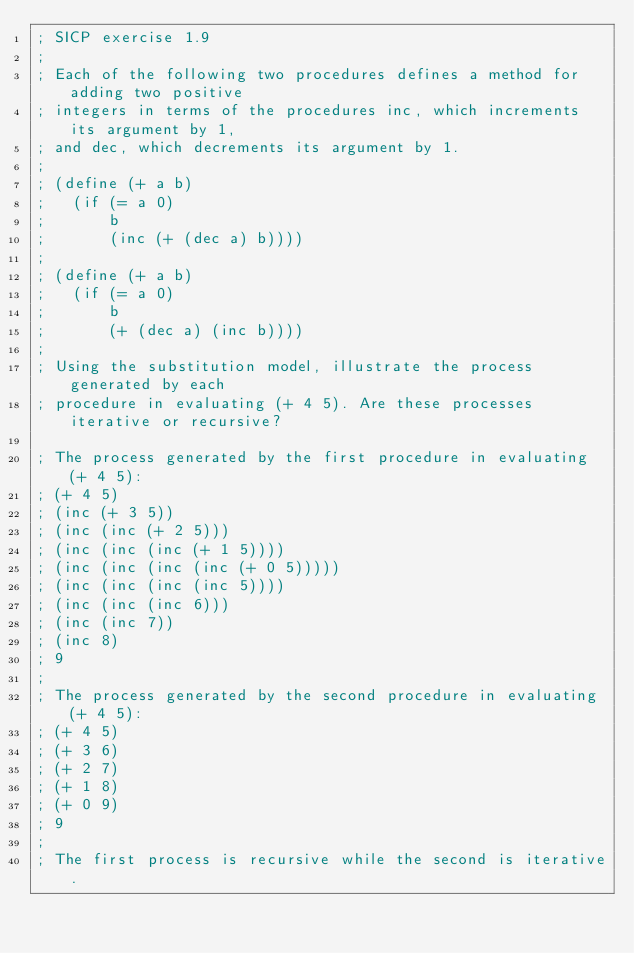<code> <loc_0><loc_0><loc_500><loc_500><_Scheme_>; SICP exercise 1.9
;
; Each of the following two procedures defines a method for adding two positive
; integers in terms of the procedures inc, which increments its argument by 1,
; and dec, which decrements its argument by 1.
;
; (define (+ a b)
;   (if (= a 0)
;       b
;       (inc (+ (dec a) b))))
;
; (define (+ a b)
;   (if (= a 0)
;       b
;       (+ (dec a) (inc b))))
;
; Using the substitution model, illustrate the process generated by each
; procedure in evaluating (+ 4 5). Are these processes iterative or recursive?

; The process generated by the first procedure in evaluating (+ 4 5):
; (+ 4 5)
; (inc (+ 3 5))
; (inc (inc (+ 2 5)))
; (inc (inc (inc (+ 1 5))))
; (inc (inc (inc (inc (+ 0 5)))))
; (inc (inc (inc (inc 5))))
; (inc (inc (inc 6)))
; (inc (inc 7))
; (inc 8)
; 9
;
; The process generated by the second procedure in evaluating (+ 4 5):
; (+ 4 5)
; (+ 3 6)
; (+ 2 7)
; (+ 1 8)
; (+ 0 9)
; 9
;
; The first process is recursive while the second is iterative.
</code> 